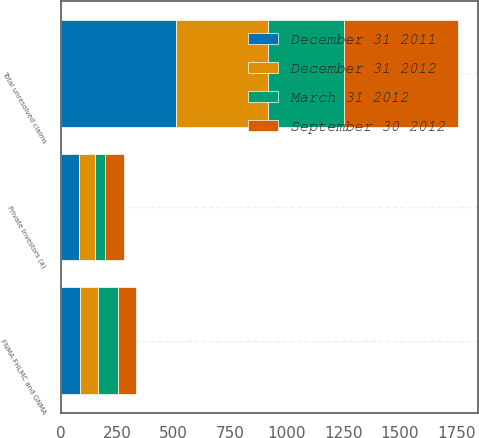<chart> <loc_0><loc_0><loc_500><loc_500><stacked_bar_chart><ecel><fcel>FNMA FHLMC and GNMA<fcel>Private Investors (a)<fcel>Total unresolved claims<nl><fcel>March 31 2012<fcel>86<fcel>47<fcel>337<nl><fcel>December 31 2011<fcel>84<fcel>82<fcel>512<nl><fcel>September 30 2012<fcel>83<fcel>83<fcel>502<nl><fcel>December 31 2012<fcel>83<fcel>69<fcel>406<nl></chart> 